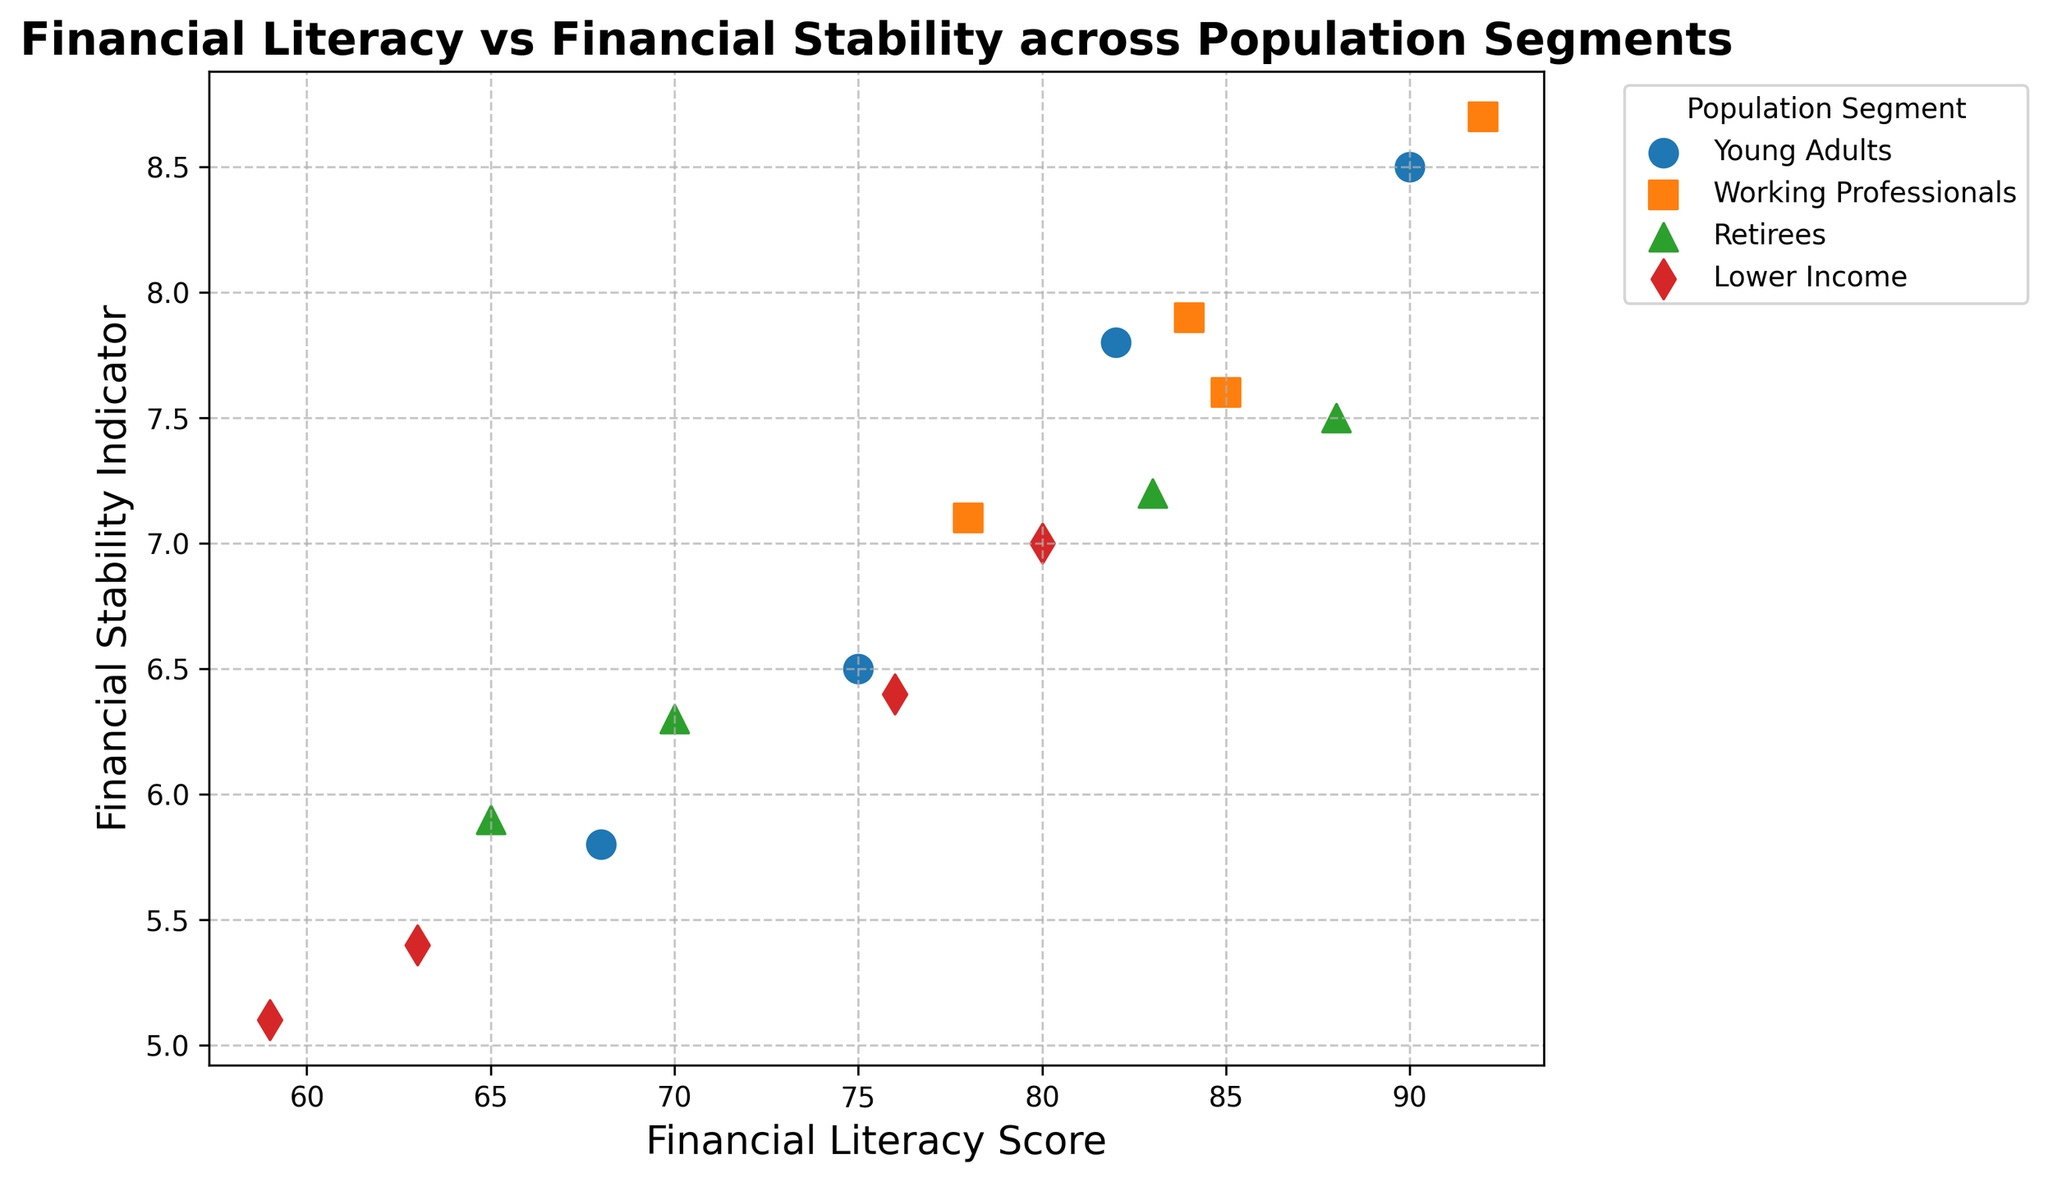What's the population segment with the highest Financial Stability Indicator on the scatter plot? The highest Financial Stability Indicator corresponds to Working Professionals who have a Financial Stability Indicator of 8.7.
Answer: Working Professionals Which population segment generally seems to have higher Financial Literacy Scores based on the scatter plot? By observing the scatter plot, it can be seen that Working Professionals have higher Financial Literacy Scores compared to other segments.
Answer: Working Professionals What is the trend between Financial Literacy Scores and Financial Stability Indicators for the Young Adults segment? The scattered points for Young Adults show a positive correlation between Financial Literacy Scores and Financial Stability Indicators. Higher literacy scores generally correspond to higher stability indicators.
Answer: Positive correlation Which population segment has the widest range of Financial Literacy Scores? By looking at the spread of data points on the x-axis, Young Adults show the widest range, spanning from 68 to 90.
Answer: Young Adults Compare the Financial Stability Indicators of Young Adults and Retirees: which group has lower stability? Comparing the positions of Young Adults and Retirees on the vertical axis, Young Adults have generally lower Financial Stability Indicators.
Answer: Young Adults What is the difference in the average Financial Literacy Scores between Lower Income and Working Professionals? Average Financial Literacy Score for Lower Income: (76 + 63 + 80 + 59)/4 = 69.5. Average for Working Professionals: (84 + 78 + 92 + 85)/4 = 84.75. The difference is 84.75 - 69.5 = 15.25
Answer: 15.25 Which segment has data points mostly clustered near the 7.0 value for Financial Stability Indicators? Observing the positions on the y-axis, Lower Income has the most data points clustered around 7.0.
Answer: Lower Income Which two segments appear closest in terms of average Financial Stability Indicator? By looking at the y-axis averages for each segment's points, Young Adults and Retirees have closer averages, near the mid-range of the Financial Stability Indicator.
Answer: Young Adults and Retirees What is the visual pattern of the scatter plot markers that differentiates Working Professionals from others? Working Professionals are marked with square-shaped markers that are colored in orange.
Answer: Square markers, Orange color 